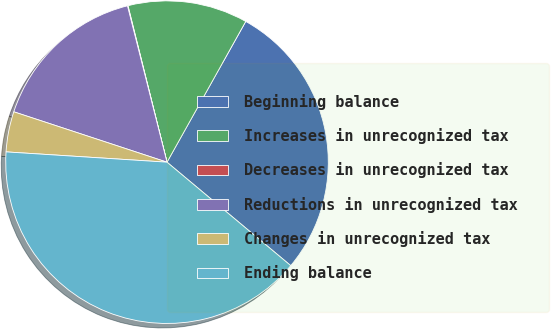Convert chart to OTSL. <chart><loc_0><loc_0><loc_500><loc_500><pie_chart><fcel>Beginning balance<fcel>Increases in unrecognized tax<fcel>Decreases in unrecognized tax<fcel>Reductions in unrecognized tax<fcel>Changes in unrecognized tax<fcel>Ending balance<nl><fcel>27.96%<fcel>12.01%<fcel>0.05%<fcel>16.0%<fcel>4.04%<fcel>39.93%<nl></chart> 